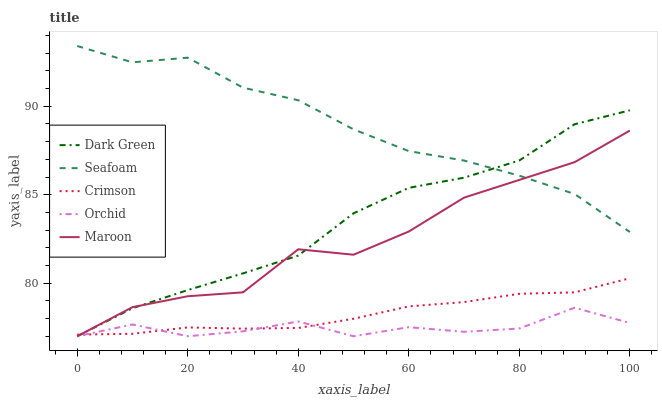Does Orchid have the minimum area under the curve?
Answer yes or no. Yes. Does Seafoam have the maximum area under the curve?
Answer yes or no. Yes. Does Seafoam have the minimum area under the curve?
Answer yes or no. No. Does Orchid have the maximum area under the curve?
Answer yes or no. No. Is Crimson the smoothest?
Answer yes or no. Yes. Is Maroon the roughest?
Answer yes or no. Yes. Is Orchid the smoothest?
Answer yes or no. No. Is Orchid the roughest?
Answer yes or no. No. Does Orchid have the lowest value?
Answer yes or no. Yes. Does Seafoam have the lowest value?
Answer yes or no. No. Does Seafoam have the highest value?
Answer yes or no. Yes. Does Orchid have the highest value?
Answer yes or no. No. Is Orchid less than Seafoam?
Answer yes or no. Yes. Is Seafoam greater than Crimson?
Answer yes or no. Yes. Does Crimson intersect Orchid?
Answer yes or no. Yes. Is Crimson less than Orchid?
Answer yes or no. No. Is Crimson greater than Orchid?
Answer yes or no. No. Does Orchid intersect Seafoam?
Answer yes or no. No. 